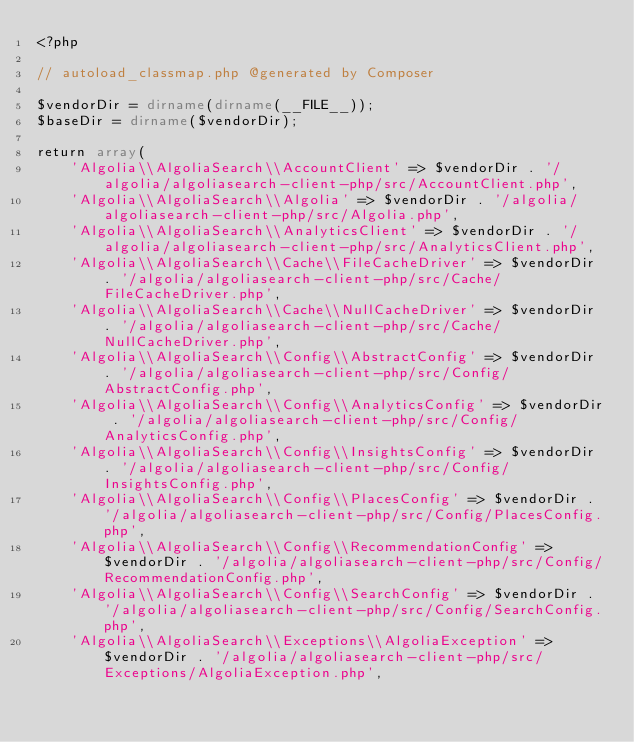<code> <loc_0><loc_0><loc_500><loc_500><_PHP_><?php

// autoload_classmap.php @generated by Composer

$vendorDir = dirname(dirname(__FILE__));
$baseDir = dirname($vendorDir);

return array(
    'Algolia\\AlgoliaSearch\\AccountClient' => $vendorDir . '/algolia/algoliasearch-client-php/src/AccountClient.php',
    'Algolia\\AlgoliaSearch\\Algolia' => $vendorDir . '/algolia/algoliasearch-client-php/src/Algolia.php',
    'Algolia\\AlgoliaSearch\\AnalyticsClient' => $vendorDir . '/algolia/algoliasearch-client-php/src/AnalyticsClient.php',
    'Algolia\\AlgoliaSearch\\Cache\\FileCacheDriver' => $vendorDir . '/algolia/algoliasearch-client-php/src/Cache/FileCacheDriver.php',
    'Algolia\\AlgoliaSearch\\Cache\\NullCacheDriver' => $vendorDir . '/algolia/algoliasearch-client-php/src/Cache/NullCacheDriver.php',
    'Algolia\\AlgoliaSearch\\Config\\AbstractConfig' => $vendorDir . '/algolia/algoliasearch-client-php/src/Config/AbstractConfig.php',
    'Algolia\\AlgoliaSearch\\Config\\AnalyticsConfig' => $vendorDir . '/algolia/algoliasearch-client-php/src/Config/AnalyticsConfig.php',
    'Algolia\\AlgoliaSearch\\Config\\InsightsConfig' => $vendorDir . '/algolia/algoliasearch-client-php/src/Config/InsightsConfig.php',
    'Algolia\\AlgoliaSearch\\Config\\PlacesConfig' => $vendorDir . '/algolia/algoliasearch-client-php/src/Config/PlacesConfig.php',
    'Algolia\\AlgoliaSearch\\Config\\RecommendationConfig' => $vendorDir . '/algolia/algoliasearch-client-php/src/Config/RecommendationConfig.php',
    'Algolia\\AlgoliaSearch\\Config\\SearchConfig' => $vendorDir . '/algolia/algoliasearch-client-php/src/Config/SearchConfig.php',
    'Algolia\\AlgoliaSearch\\Exceptions\\AlgoliaException' => $vendorDir . '/algolia/algoliasearch-client-php/src/Exceptions/AlgoliaException.php',</code> 